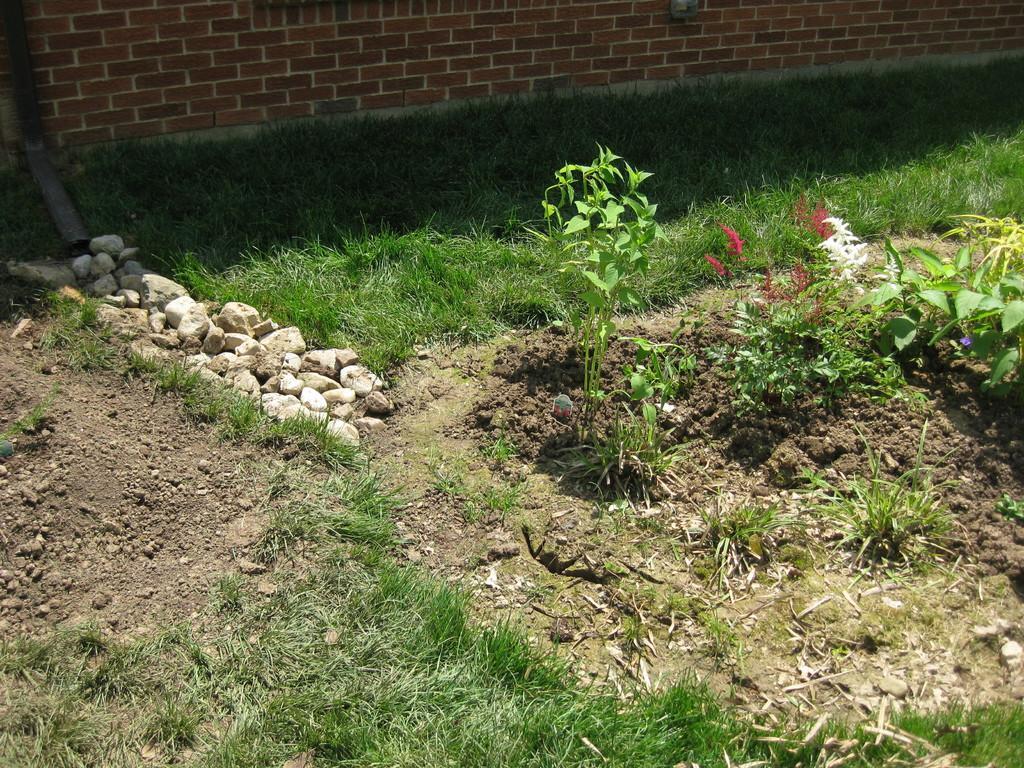Please provide a concise description of this image. In this image we can see grass, plants with flowers, stones are on the ground at the brick wall. 